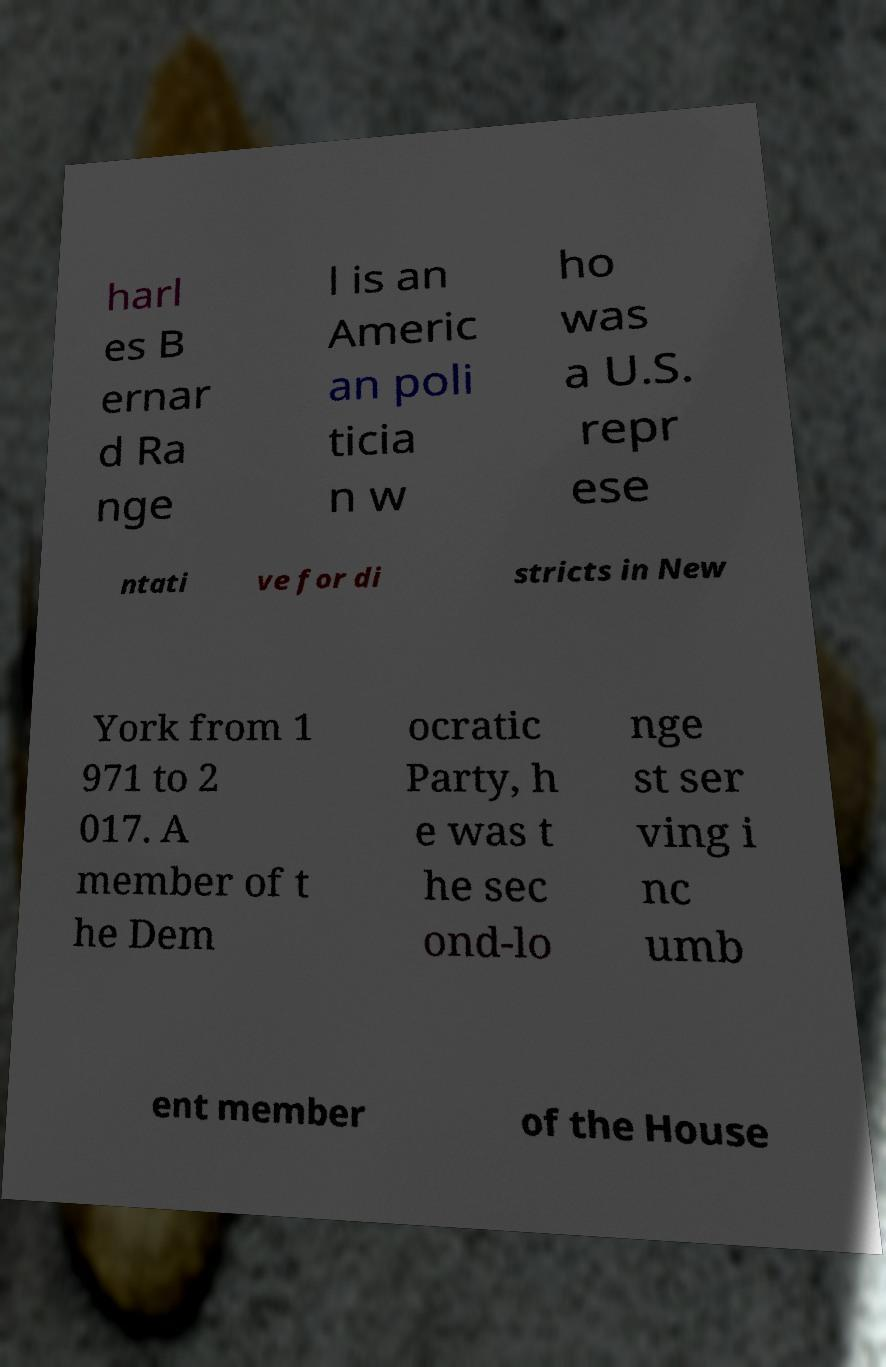What messages or text are displayed in this image? I need them in a readable, typed format. harl es B ernar d Ra nge l is an Americ an poli ticia n w ho was a U.S. repr ese ntati ve for di stricts in New York from 1 971 to 2 017. A member of t he Dem ocratic Party, h e was t he sec ond-lo nge st ser ving i nc umb ent member of the House 